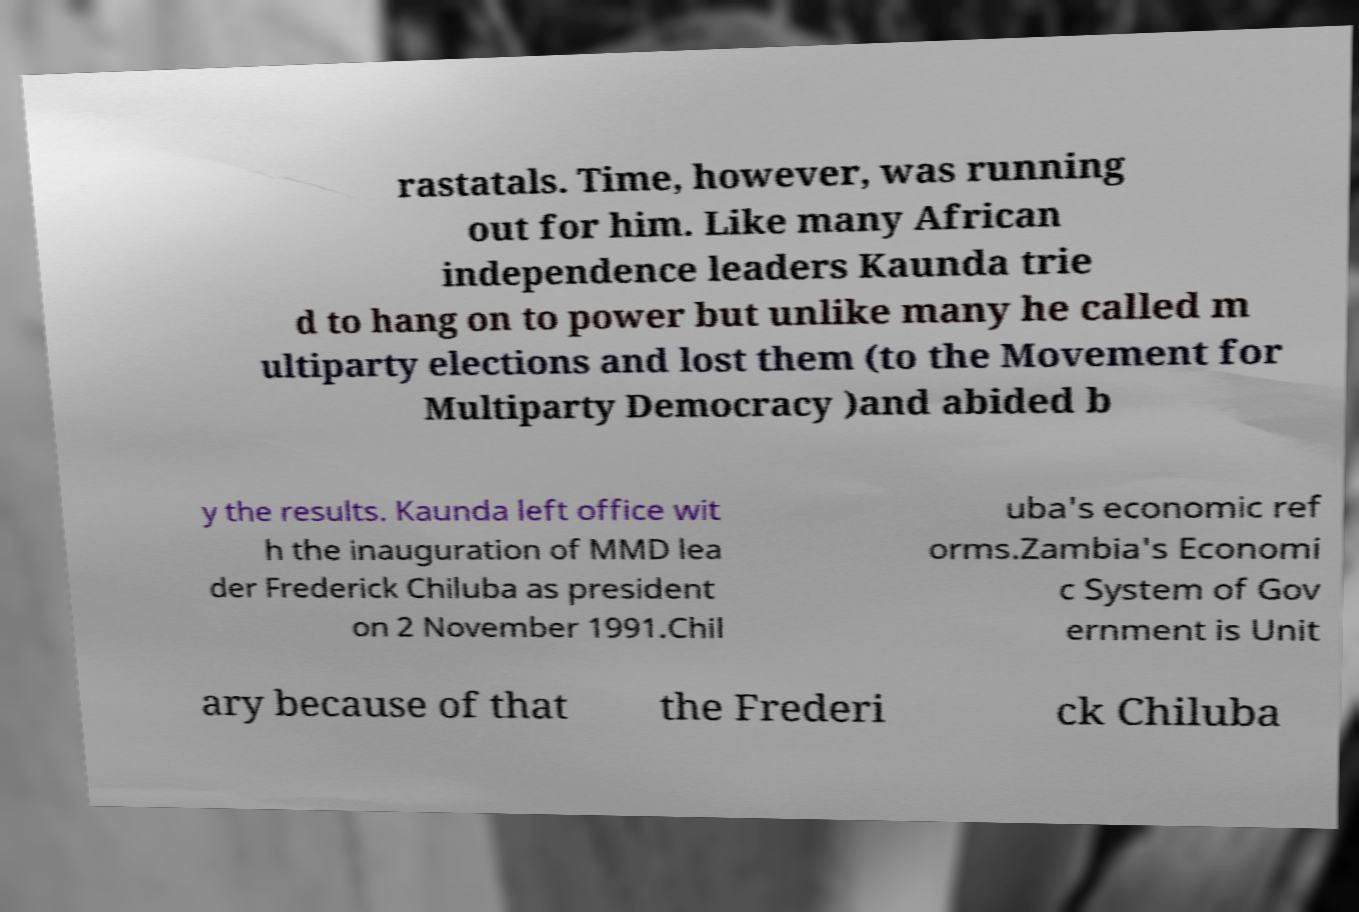Please identify and transcribe the text found in this image. rastatals. Time, however, was running out for him. Like many African independence leaders Kaunda trie d to hang on to power but unlike many he called m ultiparty elections and lost them (to the Movement for Multiparty Democracy )and abided b y the results. Kaunda left office wit h the inauguration of MMD lea der Frederick Chiluba as president on 2 November 1991.Chil uba's economic ref orms.Zambia's Economi c System of Gov ernment is Unit ary because of that the Frederi ck Chiluba 